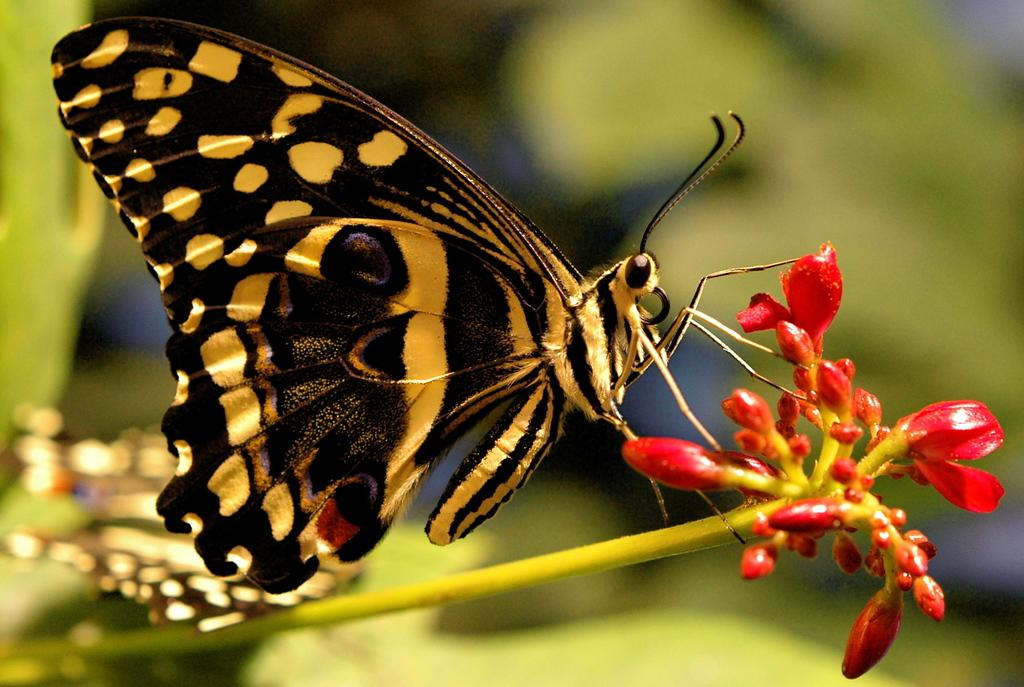What is the main subject of the image? There is a butterfly in the image. Where is the butterfly located in the image? The butterfly is on the stem of a plant. What other elements can be seen in the image? There are flowers visible in the image. How many grapes are hanging from the stem of the plant in the image? There are no grapes present in the image; it features a butterfly on the stem of a plant with flowers. 